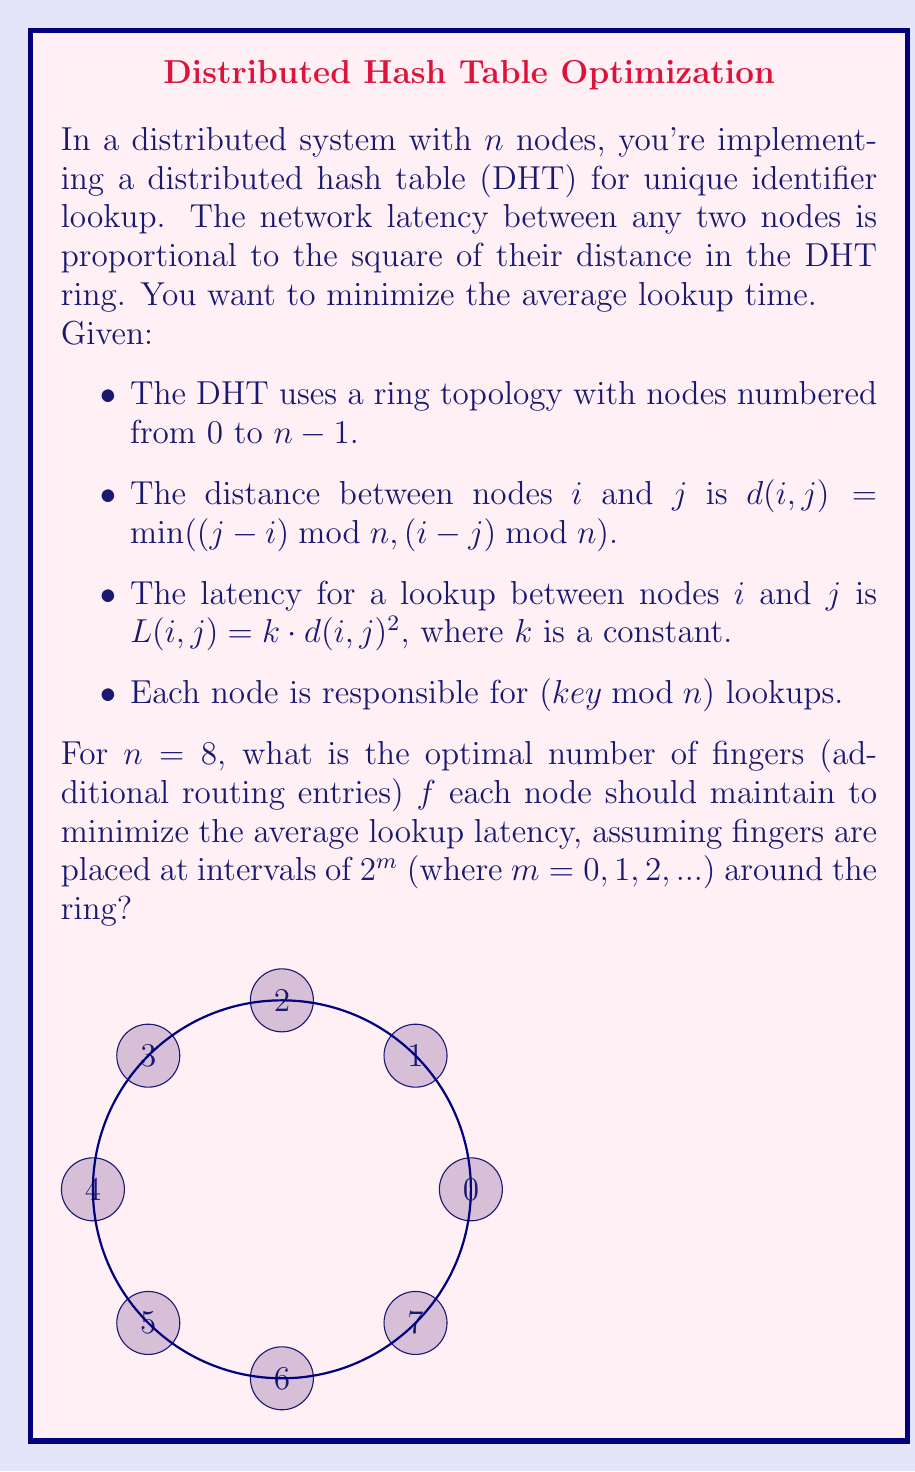Give your solution to this math problem. Let's approach this step-by-step:

1) First, we need to understand how fingers reduce lookup time. With $f$ fingers, a node can reach $2^f$ nodes in one hop.

2) The average distance for a lookup without fingers is:
   $$D_0 = \frac{1}{n} \sum_{i=1}^{n/2} i = \frac{n}{4}$$

3) With $f$ fingers, the average distance becomes:
   $$D_f = \frac{1}{n} \sum_{i=1}^{n/2^f} i = \frac{n}{2^{f+2}}$$

4) The average latency is proportional to the square of this distance:
   $$L_f = k \cdot (\frac{n}{2^{f+2}})^2 = k \cdot \frac{n^2}{4^{f+2}}$$

5) However, maintaining fingers also has a cost. Let's assume the cost is proportional to the number of fingers:
   $$C_f = c \cdot f$$
   where $c$ is some constant.

6) The total cost function is then:
   $$T_f = L_f + C_f = k \cdot \frac{n^2}{4^{f+2}} + c \cdot f$$

7) To find the minimum, we differentiate and set to zero:
   $$\frac{dT_f}{df} = -k \cdot \frac{n^2}{4^{f+2}} \cdot \ln(4) + c = 0$$

8) Solving for $f$:
   $$f = \log_4(\frac{k \cdot n^2 \cdot \ln(4)}{c}) - 2$$

9) For $n = 8$, this becomes:
   $$f = \log_4(\frac{64k \cdot \ln(4)}{c}) - 2$$

10) The optimal $f$ is the nearest integer to this value. Without knowing $k$ and $c$, we can't give an exact answer, but for reasonable values of $k$ and $c$, $f$ will typically be 2 or 3.

11) We can verify this by calculating $T_f$ for $f = 0, 1, 2, 3, 4$ and comparing the results.
Answer: 3 fingers 